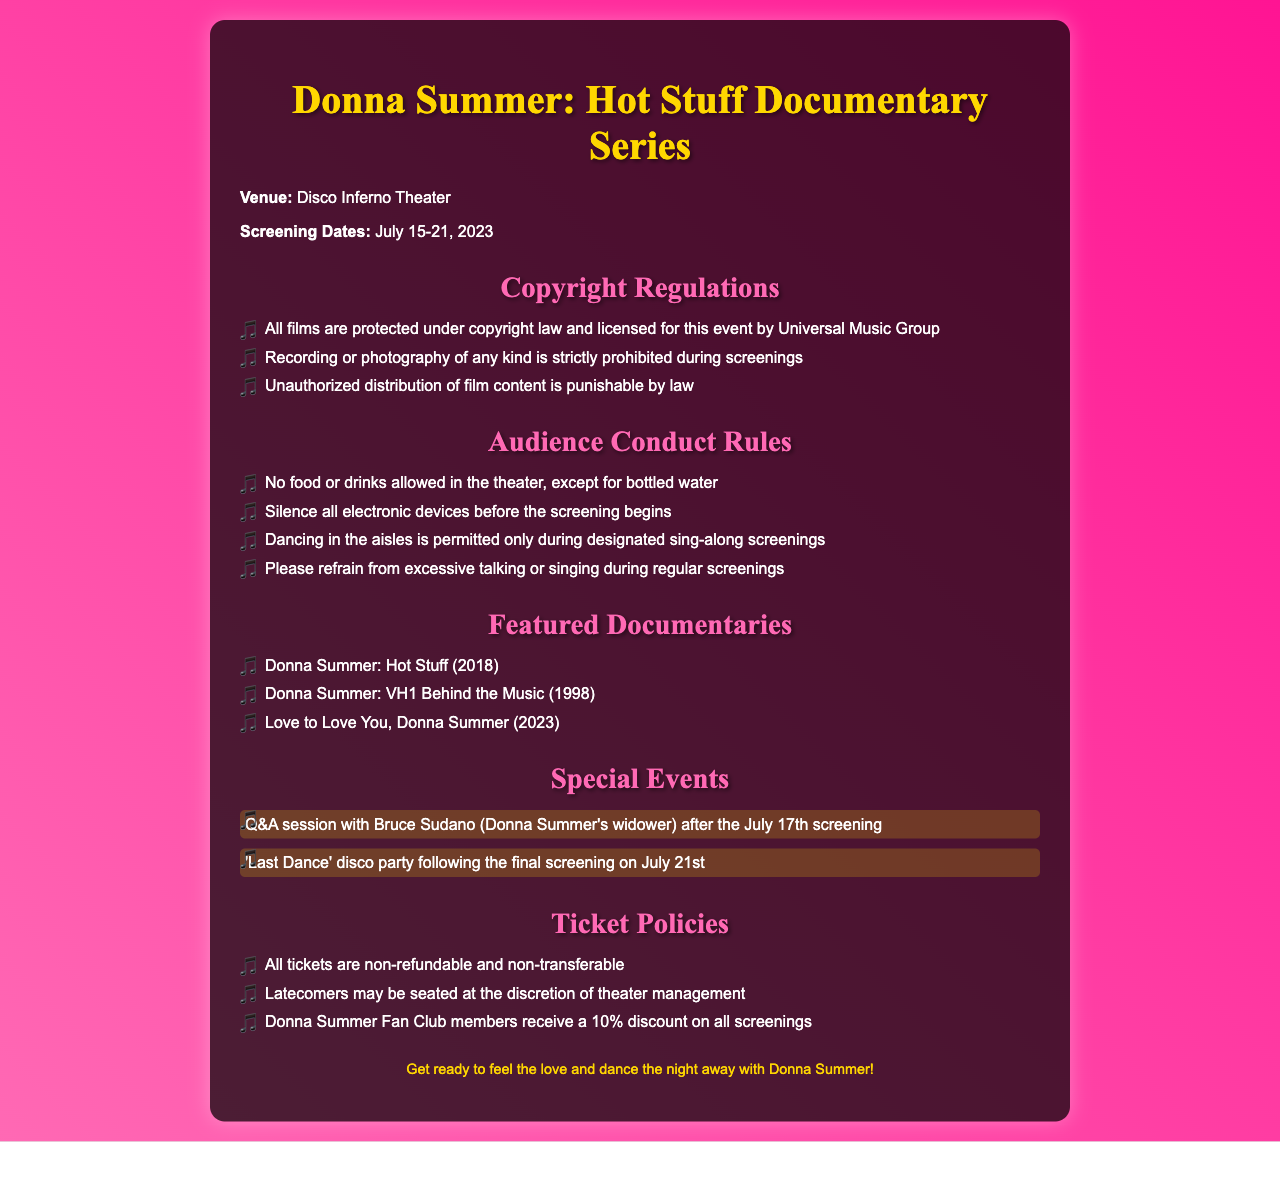What are the screening dates? The screening dates for the Donna Summer documentary series are listed in the document.
Answer: July 15-21, 2023 Who is the featured guest for the Q&A session? The document specifies that Bruce Sudano, Donna Summer's widower, will be present for a Q&A session.
Answer: Bruce Sudano What is strictly prohibited during screenings? The document provides specific regulations regarding audience conduct during the screenings.
Answer: Recording or photography What discount do Donna Summer Fan Club members receive? The document mentions a specific discount provided to members of the fan club.
Answer: 10% What event follows the final screening? The document highlights a special event that takes place after the last film screening.
Answer: 'Last Dance' disco party Is food allowed in the theater? The document outlines a rule regarding food and beverages in the theater.
Answer: No What organization licensed the films for this event? The licensing organization for the films is mentioned in the copyright section of the document.
Answer: Universal Music Group 